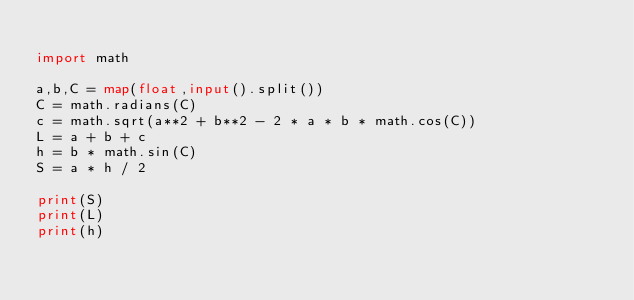Convert code to text. <code><loc_0><loc_0><loc_500><loc_500><_Python_>
import math

a,b,C = map(float,input().split())
C = math.radians(C)
c = math.sqrt(a**2 + b**2 - 2 * a * b * math.cos(C))
L = a + b + c
h = b * math.sin(C)
S = a * h / 2

print(S)
print(L)
print(h)
</code> 